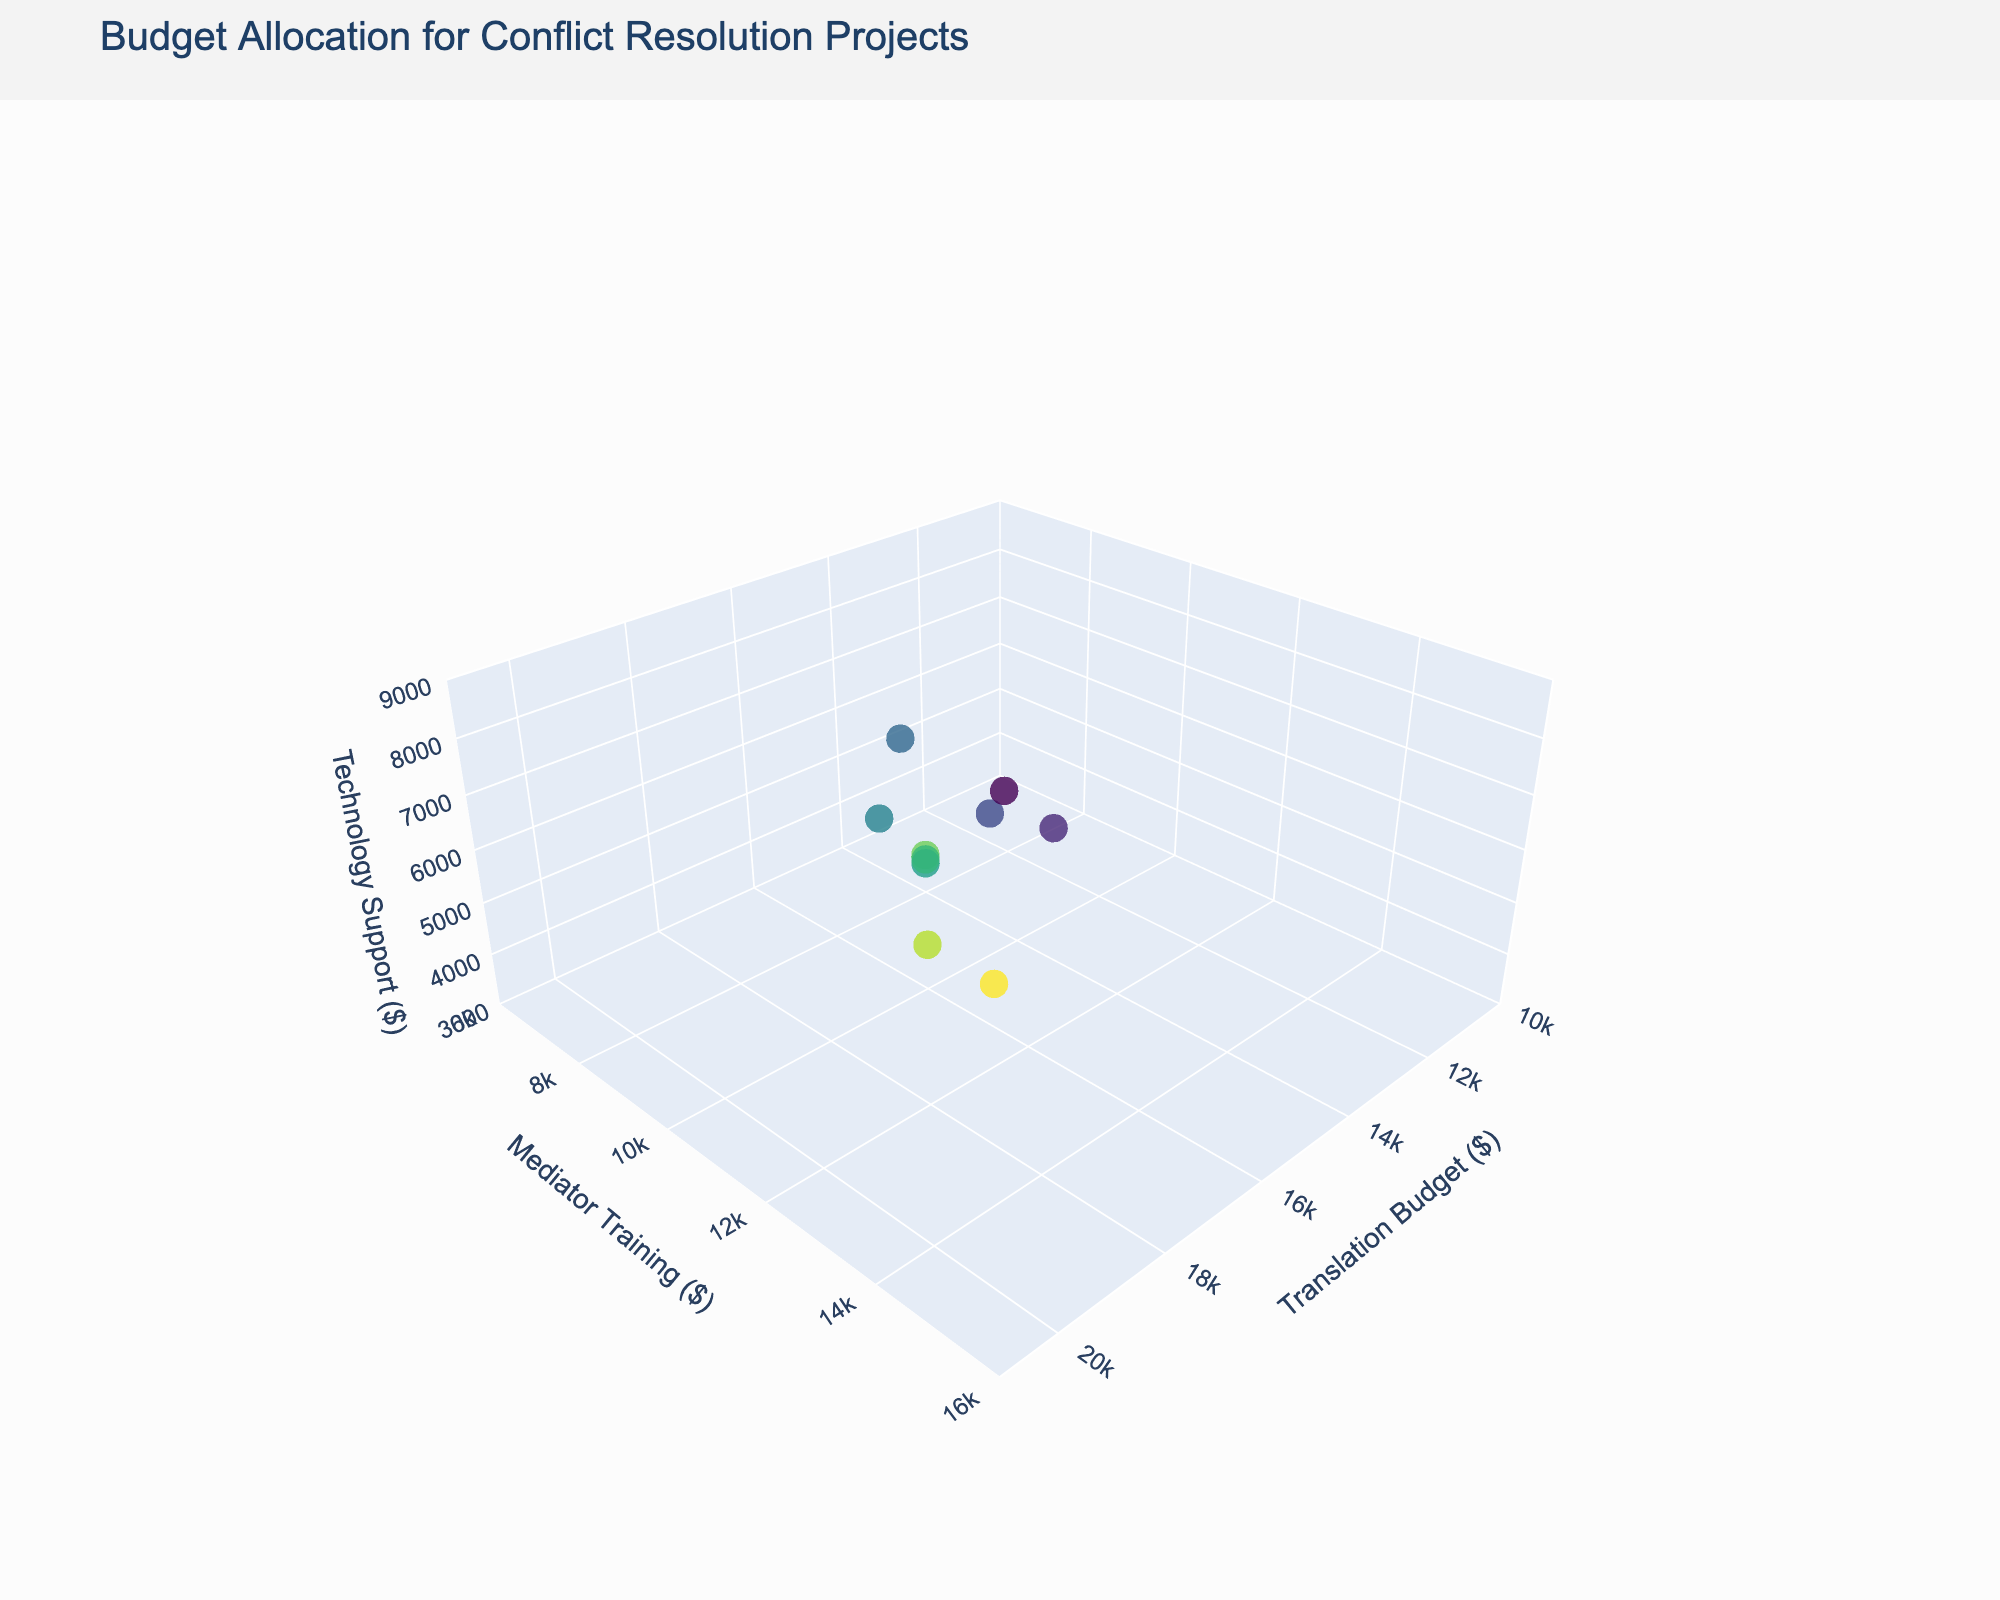What's the title of the figure? The title is usually displayed at the top of the figure. It gives a brief description of what the figure represents. Here, it indicates that the figure is about budget allocation for conflict resolution projects.
Answer: Budget Allocation for Conflict Resolution Projects Which project has the highest translation budget? By examining the x-axis (Translation Budget) and looking for the point furthest to the right, we see that the 'South Sudan Peace Talks' project has the highest translation budget.
Answer: South Sudan Peace Talks How many projects are represented in the figure? Each point on the 3D scatter plot represents a different project. By counting the points, we can identify the number of projects shown.
Answer: 10 What are the ranges for the axes in the figure? The ranges for the axes are listed in the 'scene' configuration of the layout. The x-axis (Translation Budget) ranges from 10000 to 21000, the y-axis (Mediator Training) ranges from 6000 to 16000, and the z-axis (Technology Support) ranges from 3000 to 9000. This can be verified by reading the axis labels on the figure.
Answer: Translation Budget: 10000-21000, Mediator Training: 6000-16000, Technology Support: 3000-9000 Which project has the lowest technology support budget? By examining the z-axis (Technology Support) and identifying the point closest to the x-y plane (lowest z value), we see that the 'Cyprus Bi-communal Projects' has the lowest technology support budget.
Answer: Cyprus Bi-communal Projects How do the 'Yemen Humanitarian Dialogue' and 'Israeli-Palestinian Dialogue' projects compare in terms of mediator training budget? We need to look at the y-axis values for both the 'Yemen Humanitarian Dialogue' and 'Israeli-Palestinian Dialogue' points. 'Yemen Humanitarian Dialogue' has a mediator training budget of 13000, while 'Israeli-Palestinian Dialogue' has a budget of 12000.
Answer: Yemen Humanitarian Dialogue has a higher mediator training budget What's the sum of the translation budgets for 'Syrian Refugee Integration' and 'Balkan Youth Exchange'? By adding the translation budgets for 'Syrian Refugee Integration' (15000) and 'Balkan Youth Exchange' (14000), we get a total of 29000.
Answer: 29000 Which project has a balanced or nearly equal allocation across all three budget categories? By inspecting the plot and looking for a point that is roughly equidistant from all three axes, 'Colombian Post-Conflict Mediation' appears to have a more balanced allocation: Translation Budget (17000), Mediator Training (11000), Technology Support (6500).
Answer: Colombian Post-Conflict Mediation What is the average mediator training budget for all projects? We need to sum the mediator training budgets for all projects and then divide by the number of projects. (8000 + 12000 + 9000 + 7500 + 15000 + 10000 + 8500 + 7000 + 11000 + 13000) / 10 = 10100
Answer: 10100 